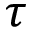<formula> <loc_0><loc_0><loc_500><loc_500>\tau</formula> 